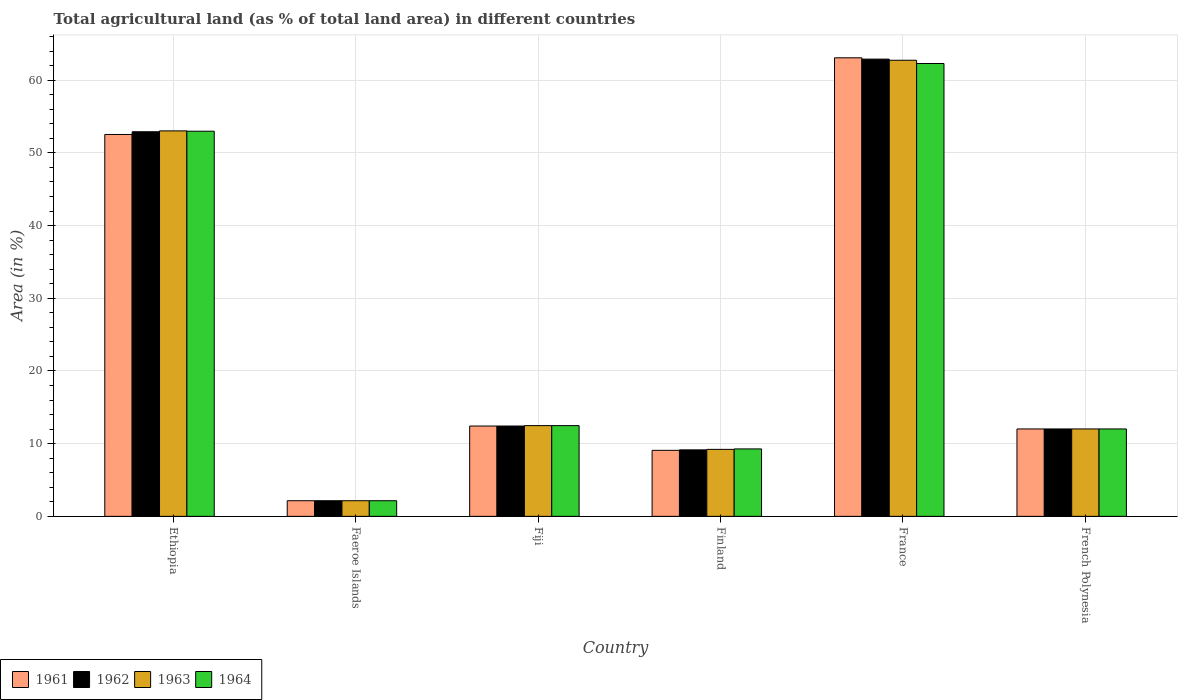How many different coloured bars are there?
Offer a very short reply. 4. How many groups of bars are there?
Your answer should be compact. 6. Are the number of bars on each tick of the X-axis equal?
Offer a very short reply. Yes. How many bars are there on the 4th tick from the left?
Your response must be concise. 4. How many bars are there on the 1st tick from the right?
Your response must be concise. 4. In how many cases, is the number of bars for a given country not equal to the number of legend labels?
Offer a very short reply. 0. What is the percentage of agricultural land in 1963 in Fiji?
Provide a succinct answer. 12.48. Across all countries, what is the maximum percentage of agricultural land in 1964?
Provide a short and direct response. 62.29. Across all countries, what is the minimum percentage of agricultural land in 1961?
Offer a terse response. 2.15. In which country was the percentage of agricultural land in 1964 minimum?
Make the answer very short. Faeroe Islands. What is the total percentage of agricultural land in 1962 in the graph?
Give a very brief answer. 151.54. What is the difference between the percentage of agricultural land in 1963 in Ethiopia and that in French Polynesia?
Make the answer very short. 41. What is the difference between the percentage of agricultural land in 1962 in Faeroe Islands and the percentage of agricultural land in 1964 in Finland?
Make the answer very short. -7.13. What is the average percentage of agricultural land in 1962 per country?
Your answer should be compact. 25.26. What is the difference between the percentage of agricultural land of/in 1963 and percentage of agricultural land of/in 1964 in Ethiopia?
Your answer should be very brief. 0.05. What is the ratio of the percentage of agricultural land in 1961 in Ethiopia to that in Fiji?
Give a very brief answer. 4.23. Is the percentage of agricultural land in 1963 in Faeroe Islands less than that in Finland?
Offer a terse response. Yes. Is the difference between the percentage of agricultural land in 1963 in Ethiopia and France greater than the difference between the percentage of agricultural land in 1964 in Ethiopia and France?
Offer a very short reply. No. What is the difference between the highest and the second highest percentage of agricultural land in 1962?
Keep it short and to the point. 40.48. What is the difference between the highest and the lowest percentage of agricultural land in 1963?
Ensure brevity in your answer.  60.59. In how many countries, is the percentage of agricultural land in 1964 greater than the average percentage of agricultural land in 1964 taken over all countries?
Offer a terse response. 2. What does the 4th bar from the left in Finland represents?
Your response must be concise. 1964. What does the 1st bar from the right in Faeroe Islands represents?
Ensure brevity in your answer.  1964. Is it the case that in every country, the sum of the percentage of agricultural land in 1962 and percentage of agricultural land in 1963 is greater than the percentage of agricultural land in 1961?
Provide a short and direct response. Yes. How many countries are there in the graph?
Give a very brief answer. 6. Are the values on the major ticks of Y-axis written in scientific E-notation?
Offer a terse response. No. Where does the legend appear in the graph?
Ensure brevity in your answer.  Bottom left. What is the title of the graph?
Your response must be concise. Total agricultural land (as % of total land area) in different countries. Does "1965" appear as one of the legend labels in the graph?
Keep it short and to the point. No. What is the label or title of the X-axis?
Offer a terse response. Country. What is the label or title of the Y-axis?
Offer a terse response. Area (in %). What is the Area (in %) of 1961 in Ethiopia?
Offer a very short reply. 52.53. What is the Area (in %) of 1962 in Ethiopia?
Offer a very short reply. 52.91. What is the Area (in %) of 1963 in Ethiopia?
Give a very brief answer. 53.02. What is the Area (in %) of 1964 in Ethiopia?
Ensure brevity in your answer.  52.98. What is the Area (in %) in 1961 in Faeroe Islands?
Offer a very short reply. 2.15. What is the Area (in %) of 1962 in Faeroe Islands?
Offer a very short reply. 2.15. What is the Area (in %) in 1963 in Faeroe Islands?
Give a very brief answer. 2.15. What is the Area (in %) of 1964 in Faeroe Islands?
Your answer should be compact. 2.15. What is the Area (in %) of 1961 in Fiji?
Offer a terse response. 12.42. What is the Area (in %) of 1962 in Fiji?
Make the answer very short. 12.42. What is the Area (in %) in 1963 in Fiji?
Offer a very short reply. 12.48. What is the Area (in %) in 1964 in Fiji?
Your response must be concise. 12.48. What is the Area (in %) of 1961 in Finland?
Provide a succinct answer. 9.08. What is the Area (in %) of 1962 in Finland?
Make the answer very short. 9.14. What is the Area (in %) in 1963 in Finland?
Your answer should be very brief. 9.21. What is the Area (in %) in 1964 in Finland?
Your answer should be very brief. 9.28. What is the Area (in %) in 1961 in France?
Your answer should be compact. 63.08. What is the Area (in %) of 1962 in France?
Your answer should be compact. 62.9. What is the Area (in %) in 1963 in France?
Your answer should be very brief. 62.74. What is the Area (in %) of 1964 in France?
Your answer should be very brief. 62.29. What is the Area (in %) in 1961 in French Polynesia?
Ensure brevity in your answer.  12.02. What is the Area (in %) in 1962 in French Polynesia?
Your response must be concise. 12.02. What is the Area (in %) in 1963 in French Polynesia?
Keep it short and to the point. 12.02. What is the Area (in %) in 1964 in French Polynesia?
Provide a succinct answer. 12.02. Across all countries, what is the maximum Area (in %) in 1961?
Your answer should be very brief. 63.08. Across all countries, what is the maximum Area (in %) of 1962?
Your response must be concise. 62.9. Across all countries, what is the maximum Area (in %) in 1963?
Offer a very short reply. 62.74. Across all countries, what is the maximum Area (in %) in 1964?
Offer a very short reply. 62.29. Across all countries, what is the minimum Area (in %) in 1961?
Ensure brevity in your answer.  2.15. Across all countries, what is the minimum Area (in %) of 1962?
Give a very brief answer. 2.15. Across all countries, what is the minimum Area (in %) in 1963?
Provide a short and direct response. 2.15. Across all countries, what is the minimum Area (in %) in 1964?
Offer a very short reply. 2.15. What is the total Area (in %) in 1961 in the graph?
Offer a very short reply. 151.28. What is the total Area (in %) in 1962 in the graph?
Ensure brevity in your answer.  151.54. What is the total Area (in %) in 1963 in the graph?
Provide a short and direct response. 151.63. What is the total Area (in %) of 1964 in the graph?
Give a very brief answer. 151.2. What is the difference between the Area (in %) of 1961 in Ethiopia and that in Faeroe Islands?
Offer a very short reply. 50.38. What is the difference between the Area (in %) in 1962 in Ethiopia and that in Faeroe Islands?
Give a very brief answer. 50.76. What is the difference between the Area (in %) in 1963 in Ethiopia and that in Faeroe Islands?
Make the answer very short. 50.88. What is the difference between the Area (in %) in 1964 in Ethiopia and that in Faeroe Islands?
Offer a very short reply. 50.83. What is the difference between the Area (in %) in 1961 in Ethiopia and that in Fiji?
Provide a short and direct response. 40.11. What is the difference between the Area (in %) of 1962 in Ethiopia and that in Fiji?
Your answer should be very brief. 40.48. What is the difference between the Area (in %) in 1963 in Ethiopia and that in Fiji?
Provide a succinct answer. 40.55. What is the difference between the Area (in %) in 1964 in Ethiopia and that in Fiji?
Your answer should be compact. 40.5. What is the difference between the Area (in %) of 1961 in Ethiopia and that in Finland?
Your answer should be very brief. 43.45. What is the difference between the Area (in %) of 1962 in Ethiopia and that in Finland?
Provide a succinct answer. 43.76. What is the difference between the Area (in %) in 1963 in Ethiopia and that in Finland?
Ensure brevity in your answer.  43.81. What is the difference between the Area (in %) of 1964 in Ethiopia and that in Finland?
Offer a very short reply. 43.7. What is the difference between the Area (in %) of 1961 in Ethiopia and that in France?
Give a very brief answer. -10.55. What is the difference between the Area (in %) of 1962 in Ethiopia and that in France?
Provide a succinct answer. -9.99. What is the difference between the Area (in %) in 1963 in Ethiopia and that in France?
Provide a succinct answer. -9.71. What is the difference between the Area (in %) of 1964 in Ethiopia and that in France?
Ensure brevity in your answer.  -9.31. What is the difference between the Area (in %) of 1961 in Ethiopia and that in French Polynesia?
Ensure brevity in your answer.  40.51. What is the difference between the Area (in %) of 1962 in Ethiopia and that in French Polynesia?
Provide a short and direct response. 40.88. What is the difference between the Area (in %) of 1963 in Ethiopia and that in French Polynesia?
Your response must be concise. 41. What is the difference between the Area (in %) of 1964 in Ethiopia and that in French Polynesia?
Ensure brevity in your answer.  40.96. What is the difference between the Area (in %) in 1961 in Faeroe Islands and that in Fiji?
Keep it short and to the point. -10.28. What is the difference between the Area (in %) of 1962 in Faeroe Islands and that in Fiji?
Give a very brief answer. -10.28. What is the difference between the Area (in %) of 1963 in Faeroe Islands and that in Fiji?
Provide a short and direct response. -10.33. What is the difference between the Area (in %) in 1964 in Faeroe Islands and that in Fiji?
Offer a very short reply. -10.33. What is the difference between the Area (in %) of 1961 in Faeroe Islands and that in Finland?
Keep it short and to the point. -6.93. What is the difference between the Area (in %) in 1962 in Faeroe Islands and that in Finland?
Ensure brevity in your answer.  -6.99. What is the difference between the Area (in %) of 1963 in Faeroe Islands and that in Finland?
Give a very brief answer. -7.07. What is the difference between the Area (in %) in 1964 in Faeroe Islands and that in Finland?
Ensure brevity in your answer.  -7.13. What is the difference between the Area (in %) in 1961 in Faeroe Islands and that in France?
Keep it short and to the point. -60.93. What is the difference between the Area (in %) of 1962 in Faeroe Islands and that in France?
Offer a very short reply. -60.75. What is the difference between the Area (in %) in 1963 in Faeroe Islands and that in France?
Provide a short and direct response. -60.59. What is the difference between the Area (in %) of 1964 in Faeroe Islands and that in France?
Give a very brief answer. -60.14. What is the difference between the Area (in %) of 1961 in Faeroe Islands and that in French Polynesia?
Your answer should be compact. -9.87. What is the difference between the Area (in %) in 1962 in Faeroe Islands and that in French Polynesia?
Give a very brief answer. -9.87. What is the difference between the Area (in %) in 1963 in Faeroe Islands and that in French Polynesia?
Provide a succinct answer. -9.87. What is the difference between the Area (in %) in 1964 in Faeroe Islands and that in French Polynesia?
Give a very brief answer. -9.87. What is the difference between the Area (in %) in 1961 in Fiji and that in Finland?
Provide a short and direct response. 3.34. What is the difference between the Area (in %) of 1962 in Fiji and that in Finland?
Your response must be concise. 3.28. What is the difference between the Area (in %) of 1963 in Fiji and that in Finland?
Your response must be concise. 3.27. What is the difference between the Area (in %) in 1964 in Fiji and that in Finland?
Your answer should be compact. 3.2. What is the difference between the Area (in %) of 1961 in Fiji and that in France?
Your answer should be very brief. -50.65. What is the difference between the Area (in %) of 1962 in Fiji and that in France?
Provide a succinct answer. -50.47. What is the difference between the Area (in %) of 1963 in Fiji and that in France?
Your answer should be compact. -50.26. What is the difference between the Area (in %) of 1964 in Fiji and that in France?
Your answer should be very brief. -49.81. What is the difference between the Area (in %) in 1961 in Fiji and that in French Polynesia?
Your answer should be very brief. 0.4. What is the difference between the Area (in %) of 1962 in Fiji and that in French Polynesia?
Your answer should be compact. 0.4. What is the difference between the Area (in %) in 1963 in Fiji and that in French Polynesia?
Your response must be concise. 0.46. What is the difference between the Area (in %) in 1964 in Fiji and that in French Polynesia?
Keep it short and to the point. 0.46. What is the difference between the Area (in %) in 1961 in Finland and that in France?
Provide a short and direct response. -54. What is the difference between the Area (in %) of 1962 in Finland and that in France?
Give a very brief answer. -53.75. What is the difference between the Area (in %) in 1963 in Finland and that in France?
Make the answer very short. -53.53. What is the difference between the Area (in %) in 1964 in Finland and that in France?
Offer a very short reply. -53.02. What is the difference between the Area (in %) in 1961 in Finland and that in French Polynesia?
Your response must be concise. -2.94. What is the difference between the Area (in %) in 1962 in Finland and that in French Polynesia?
Give a very brief answer. -2.88. What is the difference between the Area (in %) of 1963 in Finland and that in French Polynesia?
Offer a very short reply. -2.81. What is the difference between the Area (in %) in 1964 in Finland and that in French Polynesia?
Ensure brevity in your answer.  -2.75. What is the difference between the Area (in %) of 1961 in France and that in French Polynesia?
Provide a short and direct response. 51.06. What is the difference between the Area (in %) in 1962 in France and that in French Polynesia?
Your answer should be very brief. 50.87. What is the difference between the Area (in %) in 1963 in France and that in French Polynesia?
Your response must be concise. 50.72. What is the difference between the Area (in %) in 1964 in France and that in French Polynesia?
Give a very brief answer. 50.27. What is the difference between the Area (in %) in 1961 in Ethiopia and the Area (in %) in 1962 in Faeroe Islands?
Give a very brief answer. 50.38. What is the difference between the Area (in %) in 1961 in Ethiopia and the Area (in %) in 1963 in Faeroe Islands?
Keep it short and to the point. 50.38. What is the difference between the Area (in %) in 1961 in Ethiopia and the Area (in %) in 1964 in Faeroe Islands?
Offer a terse response. 50.38. What is the difference between the Area (in %) of 1962 in Ethiopia and the Area (in %) of 1963 in Faeroe Islands?
Keep it short and to the point. 50.76. What is the difference between the Area (in %) of 1962 in Ethiopia and the Area (in %) of 1964 in Faeroe Islands?
Offer a very short reply. 50.76. What is the difference between the Area (in %) of 1963 in Ethiopia and the Area (in %) of 1964 in Faeroe Islands?
Your answer should be compact. 50.88. What is the difference between the Area (in %) in 1961 in Ethiopia and the Area (in %) in 1962 in Fiji?
Your answer should be compact. 40.11. What is the difference between the Area (in %) of 1961 in Ethiopia and the Area (in %) of 1963 in Fiji?
Give a very brief answer. 40.05. What is the difference between the Area (in %) of 1961 in Ethiopia and the Area (in %) of 1964 in Fiji?
Make the answer very short. 40.05. What is the difference between the Area (in %) in 1962 in Ethiopia and the Area (in %) in 1963 in Fiji?
Your answer should be very brief. 40.43. What is the difference between the Area (in %) of 1962 in Ethiopia and the Area (in %) of 1964 in Fiji?
Your answer should be compact. 40.43. What is the difference between the Area (in %) of 1963 in Ethiopia and the Area (in %) of 1964 in Fiji?
Your answer should be very brief. 40.55. What is the difference between the Area (in %) of 1961 in Ethiopia and the Area (in %) of 1962 in Finland?
Give a very brief answer. 43.39. What is the difference between the Area (in %) in 1961 in Ethiopia and the Area (in %) in 1963 in Finland?
Your answer should be very brief. 43.32. What is the difference between the Area (in %) in 1961 in Ethiopia and the Area (in %) in 1964 in Finland?
Keep it short and to the point. 43.25. What is the difference between the Area (in %) of 1962 in Ethiopia and the Area (in %) of 1963 in Finland?
Make the answer very short. 43.69. What is the difference between the Area (in %) in 1962 in Ethiopia and the Area (in %) in 1964 in Finland?
Provide a succinct answer. 43.63. What is the difference between the Area (in %) in 1963 in Ethiopia and the Area (in %) in 1964 in Finland?
Offer a terse response. 43.75. What is the difference between the Area (in %) of 1961 in Ethiopia and the Area (in %) of 1962 in France?
Offer a terse response. -10.37. What is the difference between the Area (in %) of 1961 in Ethiopia and the Area (in %) of 1963 in France?
Ensure brevity in your answer.  -10.21. What is the difference between the Area (in %) in 1961 in Ethiopia and the Area (in %) in 1964 in France?
Ensure brevity in your answer.  -9.76. What is the difference between the Area (in %) of 1962 in Ethiopia and the Area (in %) of 1963 in France?
Make the answer very short. -9.83. What is the difference between the Area (in %) in 1962 in Ethiopia and the Area (in %) in 1964 in France?
Give a very brief answer. -9.39. What is the difference between the Area (in %) of 1963 in Ethiopia and the Area (in %) of 1964 in France?
Your answer should be compact. -9.27. What is the difference between the Area (in %) in 1961 in Ethiopia and the Area (in %) in 1962 in French Polynesia?
Keep it short and to the point. 40.51. What is the difference between the Area (in %) in 1961 in Ethiopia and the Area (in %) in 1963 in French Polynesia?
Give a very brief answer. 40.51. What is the difference between the Area (in %) of 1961 in Ethiopia and the Area (in %) of 1964 in French Polynesia?
Provide a succinct answer. 40.51. What is the difference between the Area (in %) in 1962 in Ethiopia and the Area (in %) in 1963 in French Polynesia?
Offer a terse response. 40.88. What is the difference between the Area (in %) of 1962 in Ethiopia and the Area (in %) of 1964 in French Polynesia?
Give a very brief answer. 40.88. What is the difference between the Area (in %) in 1963 in Ethiopia and the Area (in %) in 1964 in French Polynesia?
Keep it short and to the point. 41. What is the difference between the Area (in %) in 1961 in Faeroe Islands and the Area (in %) in 1962 in Fiji?
Your answer should be very brief. -10.28. What is the difference between the Area (in %) of 1961 in Faeroe Islands and the Area (in %) of 1963 in Fiji?
Offer a very short reply. -10.33. What is the difference between the Area (in %) in 1961 in Faeroe Islands and the Area (in %) in 1964 in Fiji?
Offer a very short reply. -10.33. What is the difference between the Area (in %) of 1962 in Faeroe Islands and the Area (in %) of 1963 in Fiji?
Keep it short and to the point. -10.33. What is the difference between the Area (in %) in 1962 in Faeroe Islands and the Area (in %) in 1964 in Fiji?
Keep it short and to the point. -10.33. What is the difference between the Area (in %) in 1963 in Faeroe Islands and the Area (in %) in 1964 in Fiji?
Give a very brief answer. -10.33. What is the difference between the Area (in %) in 1961 in Faeroe Islands and the Area (in %) in 1962 in Finland?
Give a very brief answer. -6.99. What is the difference between the Area (in %) of 1961 in Faeroe Islands and the Area (in %) of 1963 in Finland?
Offer a very short reply. -7.07. What is the difference between the Area (in %) in 1961 in Faeroe Islands and the Area (in %) in 1964 in Finland?
Give a very brief answer. -7.13. What is the difference between the Area (in %) of 1962 in Faeroe Islands and the Area (in %) of 1963 in Finland?
Provide a succinct answer. -7.07. What is the difference between the Area (in %) of 1962 in Faeroe Islands and the Area (in %) of 1964 in Finland?
Your response must be concise. -7.13. What is the difference between the Area (in %) in 1963 in Faeroe Islands and the Area (in %) in 1964 in Finland?
Your response must be concise. -7.13. What is the difference between the Area (in %) in 1961 in Faeroe Islands and the Area (in %) in 1962 in France?
Offer a very short reply. -60.75. What is the difference between the Area (in %) in 1961 in Faeroe Islands and the Area (in %) in 1963 in France?
Make the answer very short. -60.59. What is the difference between the Area (in %) of 1961 in Faeroe Islands and the Area (in %) of 1964 in France?
Provide a short and direct response. -60.14. What is the difference between the Area (in %) in 1962 in Faeroe Islands and the Area (in %) in 1963 in France?
Your answer should be compact. -60.59. What is the difference between the Area (in %) in 1962 in Faeroe Islands and the Area (in %) in 1964 in France?
Give a very brief answer. -60.14. What is the difference between the Area (in %) in 1963 in Faeroe Islands and the Area (in %) in 1964 in France?
Provide a succinct answer. -60.14. What is the difference between the Area (in %) in 1961 in Faeroe Islands and the Area (in %) in 1962 in French Polynesia?
Provide a succinct answer. -9.87. What is the difference between the Area (in %) of 1961 in Faeroe Islands and the Area (in %) of 1963 in French Polynesia?
Provide a short and direct response. -9.87. What is the difference between the Area (in %) of 1961 in Faeroe Islands and the Area (in %) of 1964 in French Polynesia?
Offer a terse response. -9.87. What is the difference between the Area (in %) of 1962 in Faeroe Islands and the Area (in %) of 1963 in French Polynesia?
Offer a terse response. -9.87. What is the difference between the Area (in %) of 1962 in Faeroe Islands and the Area (in %) of 1964 in French Polynesia?
Offer a terse response. -9.87. What is the difference between the Area (in %) of 1963 in Faeroe Islands and the Area (in %) of 1964 in French Polynesia?
Provide a succinct answer. -9.87. What is the difference between the Area (in %) in 1961 in Fiji and the Area (in %) in 1962 in Finland?
Provide a short and direct response. 3.28. What is the difference between the Area (in %) of 1961 in Fiji and the Area (in %) of 1963 in Finland?
Make the answer very short. 3.21. What is the difference between the Area (in %) of 1961 in Fiji and the Area (in %) of 1964 in Finland?
Provide a short and direct response. 3.15. What is the difference between the Area (in %) in 1962 in Fiji and the Area (in %) in 1963 in Finland?
Offer a very short reply. 3.21. What is the difference between the Area (in %) of 1962 in Fiji and the Area (in %) of 1964 in Finland?
Offer a very short reply. 3.15. What is the difference between the Area (in %) of 1963 in Fiji and the Area (in %) of 1964 in Finland?
Make the answer very short. 3.2. What is the difference between the Area (in %) in 1961 in Fiji and the Area (in %) in 1962 in France?
Your response must be concise. -50.47. What is the difference between the Area (in %) in 1961 in Fiji and the Area (in %) in 1963 in France?
Keep it short and to the point. -50.31. What is the difference between the Area (in %) in 1961 in Fiji and the Area (in %) in 1964 in France?
Provide a short and direct response. -49.87. What is the difference between the Area (in %) in 1962 in Fiji and the Area (in %) in 1963 in France?
Make the answer very short. -50.31. What is the difference between the Area (in %) in 1962 in Fiji and the Area (in %) in 1964 in France?
Your response must be concise. -49.87. What is the difference between the Area (in %) of 1963 in Fiji and the Area (in %) of 1964 in France?
Provide a short and direct response. -49.81. What is the difference between the Area (in %) of 1961 in Fiji and the Area (in %) of 1962 in French Polynesia?
Your answer should be compact. 0.4. What is the difference between the Area (in %) in 1961 in Fiji and the Area (in %) in 1963 in French Polynesia?
Keep it short and to the point. 0.4. What is the difference between the Area (in %) in 1961 in Fiji and the Area (in %) in 1964 in French Polynesia?
Offer a very short reply. 0.4. What is the difference between the Area (in %) in 1962 in Fiji and the Area (in %) in 1963 in French Polynesia?
Offer a very short reply. 0.4. What is the difference between the Area (in %) in 1962 in Fiji and the Area (in %) in 1964 in French Polynesia?
Make the answer very short. 0.4. What is the difference between the Area (in %) in 1963 in Fiji and the Area (in %) in 1964 in French Polynesia?
Make the answer very short. 0.46. What is the difference between the Area (in %) of 1961 in Finland and the Area (in %) of 1962 in France?
Offer a terse response. -53.82. What is the difference between the Area (in %) in 1961 in Finland and the Area (in %) in 1963 in France?
Offer a very short reply. -53.66. What is the difference between the Area (in %) in 1961 in Finland and the Area (in %) in 1964 in France?
Make the answer very short. -53.21. What is the difference between the Area (in %) in 1962 in Finland and the Area (in %) in 1963 in France?
Make the answer very short. -53.6. What is the difference between the Area (in %) in 1962 in Finland and the Area (in %) in 1964 in France?
Offer a very short reply. -53.15. What is the difference between the Area (in %) of 1963 in Finland and the Area (in %) of 1964 in France?
Your answer should be compact. -53.08. What is the difference between the Area (in %) of 1961 in Finland and the Area (in %) of 1962 in French Polynesia?
Your answer should be compact. -2.94. What is the difference between the Area (in %) in 1961 in Finland and the Area (in %) in 1963 in French Polynesia?
Offer a very short reply. -2.94. What is the difference between the Area (in %) of 1961 in Finland and the Area (in %) of 1964 in French Polynesia?
Ensure brevity in your answer.  -2.94. What is the difference between the Area (in %) of 1962 in Finland and the Area (in %) of 1963 in French Polynesia?
Make the answer very short. -2.88. What is the difference between the Area (in %) of 1962 in Finland and the Area (in %) of 1964 in French Polynesia?
Your answer should be compact. -2.88. What is the difference between the Area (in %) in 1963 in Finland and the Area (in %) in 1964 in French Polynesia?
Your answer should be compact. -2.81. What is the difference between the Area (in %) in 1961 in France and the Area (in %) in 1962 in French Polynesia?
Your response must be concise. 51.06. What is the difference between the Area (in %) in 1961 in France and the Area (in %) in 1963 in French Polynesia?
Offer a very short reply. 51.06. What is the difference between the Area (in %) of 1961 in France and the Area (in %) of 1964 in French Polynesia?
Offer a terse response. 51.06. What is the difference between the Area (in %) of 1962 in France and the Area (in %) of 1963 in French Polynesia?
Your response must be concise. 50.87. What is the difference between the Area (in %) in 1962 in France and the Area (in %) in 1964 in French Polynesia?
Your answer should be very brief. 50.87. What is the difference between the Area (in %) of 1963 in France and the Area (in %) of 1964 in French Polynesia?
Offer a very short reply. 50.72. What is the average Area (in %) in 1961 per country?
Provide a succinct answer. 25.21. What is the average Area (in %) of 1962 per country?
Ensure brevity in your answer.  25.26. What is the average Area (in %) in 1963 per country?
Your response must be concise. 25.27. What is the average Area (in %) in 1964 per country?
Offer a terse response. 25.2. What is the difference between the Area (in %) in 1961 and Area (in %) in 1962 in Ethiopia?
Offer a terse response. -0.38. What is the difference between the Area (in %) in 1961 and Area (in %) in 1963 in Ethiopia?
Your answer should be very brief. -0.49. What is the difference between the Area (in %) of 1961 and Area (in %) of 1964 in Ethiopia?
Ensure brevity in your answer.  -0.45. What is the difference between the Area (in %) in 1962 and Area (in %) in 1963 in Ethiopia?
Ensure brevity in your answer.  -0.12. What is the difference between the Area (in %) in 1962 and Area (in %) in 1964 in Ethiopia?
Offer a terse response. -0.07. What is the difference between the Area (in %) in 1963 and Area (in %) in 1964 in Ethiopia?
Your answer should be compact. 0.05. What is the difference between the Area (in %) of 1962 and Area (in %) of 1963 in Faeroe Islands?
Offer a terse response. 0. What is the difference between the Area (in %) of 1962 and Area (in %) of 1964 in Faeroe Islands?
Ensure brevity in your answer.  0. What is the difference between the Area (in %) in 1961 and Area (in %) in 1963 in Fiji?
Offer a terse response. -0.05. What is the difference between the Area (in %) in 1961 and Area (in %) in 1964 in Fiji?
Keep it short and to the point. -0.05. What is the difference between the Area (in %) of 1962 and Area (in %) of 1963 in Fiji?
Provide a succinct answer. -0.05. What is the difference between the Area (in %) of 1962 and Area (in %) of 1964 in Fiji?
Your answer should be very brief. -0.05. What is the difference between the Area (in %) of 1961 and Area (in %) of 1962 in Finland?
Your response must be concise. -0.06. What is the difference between the Area (in %) in 1961 and Area (in %) in 1963 in Finland?
Make the answer very short. -0.13. What is the difference between the Area (in %) in 1961 and Area (in %) in 1964 in Finland?
Your answer should be very brief. -0.2. What is the difference between the Area (in %) of 1962 and Area (in %) of 1963 in Finland?
Keep it short and to the point. -0.07. What is the difference between the Area (in %) of 1962 and Area (in %) of 1964 in Finland?
Make the answer very short. -0.13. What is the difference between the Area (in %) of 1963 and Area (in %) of 1964 in Finland?
Provide a short and direct response. -0.06. What is the difference between the Area (in %) of 1961 and Area (in %) of 1962 in France?
Provide a short and direct response. 0.18. What is the difference between the Area (in %) in 1961 and Area (in %) in 1963 in France?
Give a very brief answer. 0.34. What is the difference between the Area (in %) of 1961 and Area (in %) of 1964 in France?
Provide a succinct answer. 0.79. What is the difference between the Area (in %) in 1962 and Area (in %) in 1963 in France?
Make the answer very short. 0.16. What is the difference between the Area (in %) of 1962 and Area (in %) of 1964 in France?
Provide a succinct answer. 0.6. What is the difference between the Area (in %) in 1963 and Area (in %) in 1964 in France?
Your answer should be compact. 0.45. What is the difference between the Area (in %) in 1961 and Area (in %) in 1962 in French Polynesia?
Provide a short and direct response. 0. What is the ratio of the Area (in %) of 1961 in Ethiopia to that in Faeroe Islands?
Ensure brevity in your answer.  24.44. What is the ratio of the Area (in %) in 1962 in Ethiopia to that in Faeroe Islands?
Provide a short and direct response. 24.62. What is the ratio of the Area (in %) in 1963 in Ethiopia to that in Faeroe Islands?
Your answer should be very brief. 24.67. What is the ratio of the Area (in %) of 1964 in Ethiopia to that in Faeroe Islands?
Offer a very short reply. 24.65. What is the ratio of the Area (in %) of 1961 in Ethiopia to that in Fiji?
Ensure brevity in your answer.  4.23. What is the ratio of the Area (in %) of 1962 in Ethiopia to that in Fiji?
Ensure brevity in your answer.  4.26. What is the ratio of the Area (in %) in 1963 in Ethiopia to that in Fiji?
Provide a short and direct response. 4.25. What is the ratio of the Area (in %) in 1964 in Ethiopia to that in Fiji?
Make the answer very short. 4.25. What is the ratio of the Area (in %) in 1961 in Ethiopia to that in Finland?
Your answer should be compact. 5.79. What is the ratio of the Area (in %) in 1962 in Ethiopia to that in Finland?
Provide a short and direct response. 5.79. What is the ratio of the Area (in %) of 1963 in Ethiopia to that in Finland?
Your answer should be compact. 5.75. What is the ratio of the Area (in %) in 1964 in Ethiopia to that in Finland?
Provide a short and direct response. 5.71. What is the ratio of the Area (in %) in 1961 in Ethiopia to that in France?
Offer a very short reply. 0.83. What is the ratio of the Area (in %) of 1962 in Ethiopia to that in France?
Provide a succinct answer. 0.84. What is the ratio of the Area (in %) in 1963 in Ethiopia to that in France?
Your answer should be compact. 0.85. What is the ratio of the Area (in %) of 1964 in Ethiopia to that in France?
Keep it short and to the point. 0.85. What is the ratio of the Area (in %) in 1961 in Ethiopia to that in French Polynesia?
Your answer should be compact. 4.37. What is the ratio of the Area (in %) in 1962 in Ethiopia to that in French Polynesia?
Ensure brevity in your answer.  4.4. What is the ratio of the Area (in %) of 1963 in Ethiopia to that in French Polynesia?
Your answer should be compact. 4.41. What is the ratio of the Area (in %) of 1964 in Ethiopia to that in French Polynesia?
Keep it short and to the point. 4.41. What is the ratio of the Area (in %) of 1961 in Faeroe Islands to that in Fiji?
Make the answer very short. 0.17. What is the ratio of the Area (in %) of 1962 in Faeroe Islands to that in Fiji?
Provide a succinct answer. 0.17. What is the ratio of the Area (in %) of 1963 in Faeroe Islands to that in Fiji?
Your answer should be very brief. 0.17. What is the ratio of the Area (in %) of 1964 in Faeroe Islands to that in Fiji?
Your answer should be compact. 0.17. What is the ratio of the Area (in %) in 1961 in Faeroe Islands to that in Finland?
Your response must be concise. 0.24. What is the ratio of the Area (in %) of 1962 in Faeroe Islands to that in Finland?
Give a very brief answer. 0.23. What is the ratio of the Area (in %) of 1963 in Faeroe Islands to that in Finland?
Offer a very short reply. 0.23. What is the ratio of the Area (in %) of 1964 in Faeroe Islands to that in Finland?
Your response must be concise. 0.23. What is the ratio of the Area (in %) in 1961 in Faeroe Islands to that in France?
Your response must be concise. 0.03. What is the ratio of the Area (in %) in 1962 in Faeroe Islands to that in France?
Make the answer very short. 0.03. What is the ratio of the Area (in %) of 1963 in Faeroe Islands to that in France?
Your answer should be compact. 0.03. What is the ratio of the Area (in %) of 1964 in Faeroe Islands to that in France?
Keep it short and to the point. 0.03. What is the ratio of the Area (in %) in 1961 in Faeroe Islands to that in French Polynesia?
Provide a short and direct response. 0.18. What is the ratio of the Area (in %) of 1962 in Faeroe Islands to that in French Polynesia?
Your response must be concise. 0.18. What is the ratio of the Area (in %) in 1963 in Faeroe Islands to that in French Polynesia?
Your answer should be compact. 0.18. What is the ratio of the Area (in %) in 1964 in Faeroe Islands to that in French Polynesia?
Your response must be concise. 0.18. What is the ratio of the Area (in %) of 1961 in Fiji to that in Finland?
Offer a very short reply. 1.37. What is the ratio of the Area (in %) of 1962 in Fiji to that in Finland?
Offer a very short reply. 1.36. What is the ratio of the Area (in %) in 1963 in Fiji to that in Finland?
Ensure brevity in your answer.  1.35. What is the ratio of the Area (in %) in 1964 in Fiji to that in Finland?
Provide a succinct answer. 1.35. What is the ratio of the Area (in %) of 1961 in Fiji to that in France?
Provide a short and direct response. 0.2. What is the ratio of the Area (in %) of 1962 in Fiji to that in France?
Provide a short and direct response. 0.2. What is the ratio of the Area (in %) of 1963 in Fiji to that in France?
Your response must be concise. 0.2. What is the ratio of the Area (in %) in 1964 in Fiji to that in France?
Give a very brief answer. 0.2. What is the ratio of the Area (in %) in 1961 in Fiji to that in French Polynesia?
Ensure brevity in your answer.  1.03. What is the ratio of the Area (in %) in 1962 in Fiji to that in French Polynesia?
Give a very brief answer. 1.03. What is the ratio of the Area (in %) in 1963 in Fiji to that in French Polynesia?
Offer a terse response. 1.04. What is the ratio of the Area (in %) of 1964 in Fiji to that in French Polynesia?
Keep it short and to the point. 1.04. What is the ratio of the Area (in %) in 1961 in Finland to that in France?
Offer a terse response. 0.14. What is the ratio of the Area (in %) in 1962 in Finland to that in France?
Your answer should be very brief. 0.15. What is the ratio of the Area (in %) of 1963 in Finland to that in France?
Your answer should be very brief. 0.15. What is the ratio of the Area (in %) in 1964 in Finland to that in France?
Provide a short and direct response. 0.15. What is the ratio of the Area (in %) in 1961 in Finland to that in French Polynesia?
Keep it short and to the point. 0.76. What is the ratio of the Area (in %) of 1962 in Finland to that in French Polynesia?
Keep it short and to the point. 0.76. What is the ratio of the Area (in %) of 1963 in Finland to that in French Polynesia?
Offer a very short reply. 0.77. What is the ratio of the Area (in %) in 1964 in Finland to that in French Polynesia?
Provide a short and direct response. 0.77. What is the ratio of the Area (in %) in 1961 in France to that in French Polynesia?
Give a very brief answer. 5.25. What is the ratio of the Area (in %) in 1962 in France to that in French Polynesia?
Your response must be concise. 5.23. What is the ratio of the Area (in %) of 1963 in France to that in French Polynesia?
Offer a very short reply. 5.22. What is the ratio of the Area (in %) in 1964 in France to that in French Polynesia?
Your answer should be very brief. 5.18. What is the difference between the highest and the second highest Area (in %) of 1961?
Make the answer very short. 10.55. What is the difference between the highest and the second highest Area (in %) in 1962?
Provide a succinct answer. 9.99. What is the difference between the highest and the second highest Area (in %) in 1963?
Ensure brevity in your answer.  9.71. What is the difference between the highest and the second highest Area (in %) in 1964?
Offer a terse response. 9.31. What is the difference between the highest and the lowest Area (in %) of 1961?
Make the answer very short. 60.93. What is the difference between the highest and the lowest Area (in %) in 1962?
Keep it short and to the point. 60.75. What is the difference between the highest and the lowest Area (in %) of 1963?
Your answer should be compact. 60.59. What is the difference between the highest and the lowest Area (in %) in 1964?
Give a very brief answer. 60.14. 